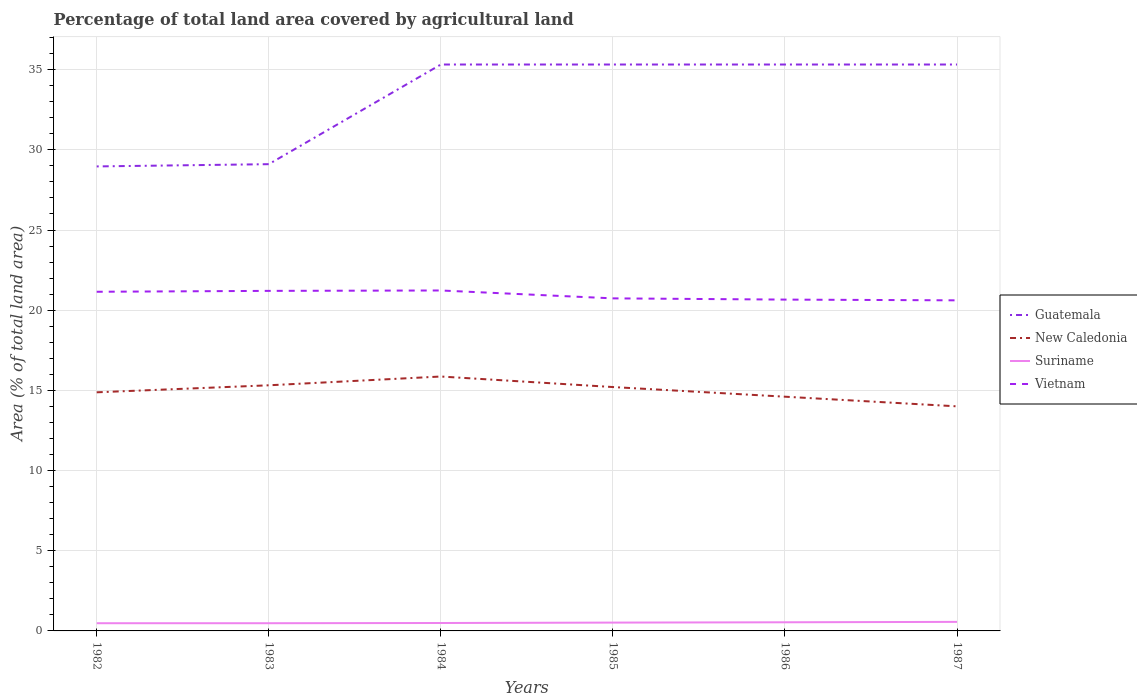How many different coloured lines are there?
Give a very brief answer. 4. Is the number of lines equal to the number of legend labels?
Make the answer very short. Yes. Across all years, what is the maximum percentage of agricultural land in Guatemala?
Offer a very short reply. 28.97. In which year was the percentage of agricultural land in Vietnam maximum?
Ensure brevity in your answer.  1987. What is the total percentage of agricultural land in Guatemala in the graph?
Your answer should be very brief. 0. What is the difference between the highest and the second highest percentage of agricultural land in New Caledonia?
Provide a succinct answer. 1.86. How many years are there in the graph?
Make the answer very short. 6. How many legend labels are there?
Make the answer very short. 4. What is the title of the graph?
Your answer should be very brief. Percentage of total land area covered by agricultural land. Does "Guinea" appear as one of the legend labels in the graph?
Provide a succinct answer. No. What is the label or title of the Y-axis?
Offer a terse response. Area (% of total land area). What is the Area (% of total land area) in Guatemala in 1982?
Offer a terse response. 28.97. What is the Area (% of total land area) of New Caledonia in 1982?
Ensure brevity in your answer.  14.88. What is the Area (% of total land area) in Suriname in 1982?
Make the answer very short. 0.48. What is the Area (% of total land area) of Vietnam in 1982?
Make the answer very short. 21.15. What is the Area (% of total land area) in Guatemala in 1983?
Keep it short and to the point. 29.11. What is the Area (% of total land area) of New Caledonia in 1983?
Keep it short and to the point. 15.32. What is the Area (% of total land area) in Suriname in 1983?
Keep it short and to the point. 0.48. What is the Area (% of total land area) of Vietnam in 1983?
Your answer should be very brief. 21.2. What is the Area (% of total land area) of Guatemala in 1984?
Provide a succinct answer. 35.32. What is the Area (% of total land area) of New Caledonia in 1984?
Provide a succinct answer. 15.86. What is the Area (% of total land area) in Suriname in 1984?
Provide a short and direct response. 0.49. What is the Area (% of total land area) in Vietnam in 1984?
Give a very brief answer. 21.23. What is the Area (% of total land area) of Guatemala in 1985?
Provide a succinct answer. 35.32. What is the Area (% of total land area) in New Caledonia in 1985?
Your answer should be very brief. 15.21. What is the Area (% of total land area) of Suriname in 1985?
Provide a short and direct response. 0.52. What is the Area (% of total land area) in Vietnam in 1985?
Offer a very short reply. 20.74. What is the Area (% of total land area) in Guatemala in 1986?
Ensure brevity in your answer.  35.32. What is the Area (% of total land area) of New Caledonia in 1986?
Keep it short and to the point. 14.61. What is the Area (% of total land area) of Suriname in 1986?
Your response must be concise. 0.54. What is the Area (% of total land area) of Vietnam in 1986?
Your answer should be very brief. 20.66. What is the Area (% of total land area) in Guatemala in 1987?
Keep it short and to the point. 35.32. What is the Area (% of total land area) of New Caledonia in 1987?
Provide a short and direct response. 14. What is the Area (% of total land area) of Suriname in 1987?
Ensure brevity in your answer.  0.56. What is the Area (% of total land area) in Vietnam in 1987?
Provide a succinct answer. 20.62. Across all years, what is the maximum Area (% of total land area) of Guatemala?
Ensure brevity in your answer.  35.32. Across all years, what is the maximum Area (% of total land area) in New Caledonia?
Your answer should be compact. 15.86. Across all years, what is the maximum Area (% of total land area) in Suriname?
Make the answer very short. 0.56. Across all years, what is the maximum Area (% of total land area) of Vietnam?
Offer a very short reply. 21.23. Across all years, what is the minimum Area (% of total land area) of Guatemala?
Provide a succinct answer. 28.97. Across all years, what is the minimum Area (% of total land area) in New Caledonia?
Provide a short and direct response. 14. Across all years, what is the minimum Area (% of total land area) of Suriname?
Offer a very short reply. 0.48. Across all years, what is the minimum Area (% of total land area) of Vietnam?
Make the answer very short. 20.62. What is the total Area (% of total land area) in Guatemala in the graph?
Make the answer very short. 199.36. What is the total Area (% of total land area) in New Caledonia in the graph?
Keep it short and to the point. 89.88. What is the total Area (% of total land area) in Suriname in the graph?
Your answer should be very brief. 3.08. What is the total Area (% of total land area) of Vietnam in the graph?
Offer a very short reply. 125.6. What is the difference between the Area (% of total land area) of Guatemala in 1982 and that in 1983?
Ensure brevity in your answer.  -0.14. What is the difference between the Area (% of total land area) of New Caledonia in 1982 and that in 1983?
Offer a terse response. -0.44. What is the difference between the Area (% of total land area) of Vietnam in 1982 and that in 1983?
Your answer should be very brief. -0.06. What is the difference between the Area (% of total land area) of Guatemala in 1982 and that in 1984?
Offer a terse response. -6.36. What is the difference between the Area (% of total land area) in New Caledonia in 1982 and that in 1984?
Provide a succinct answer. -0.98. What is the difference between the Area (% of total land area) of Suriname in 1982 and that in 1984?
Make the answer very short. -0.01. What is the difference between the Area (% of total land area) in Vietnam in 1982 and that in 1984?
Your answer should be very brief. -0.08. What is the difference between the Area (% of total land area) in Guatemala in 1982 and that in 1985?
Make the answer very short. -6.36. What is the difference between the Area (% of total land area) of New Caledonia in 1982 and that in 1985?
Your response must be concise. -0.33. What is the difference between the Area (% of total land area) of Suriname in 1982 and that in 1985?
Provide a succinct answer. -0.04. What is the difference between the Area (% of total land area) of Vietnam in 1982 and that in 1985?
Give a very brief answer. 0.41. What is the difference between the Area (% of total land area) of Guatemala in 1982 and that in 1986?
Provide a succinct answer. -6.36. What is the difference between the Area (% of total land area) in New Caledonia in 1982 and that in 1986?
Offer a terse response. 0.27. What is the difference between the Area (% of total land area) in Suriname in 1982 and that in 1986?
Your answer should be very brief. -0.06. What is the difference between the Area (% of total land area) of Vietnam in 1982 and that in 1986?
Keep it short and to the point. 0.49. What is the difference between the Area (% of total land area) in Guatemala in 1982 and that in 1987?
Offer a very short reply. -6.36. What is the difference between the Area (% of total land area) of New Caledonia in 1982 and that in 1987?
Your answer should be compact. 0.88. What is the difference between the Area (% of total land area) in Suriname in 1982 and that in 1987?
Ensure brevity in your answer.  -0.08. What is the difference between the Area (% of total land area) in Vietnam in 1982 and that in 1987?
Your answer should be compact. 0.53. What is the difference between the Area (% of total land area) in Guatemala in 1983 and that in 1984?
Offer a very short reply. -6.21. What is the difference between the Area (% of total land area) of New Caledonia in 1983 and that in 1984?
Give a very brief answer. -0.55. What is the difference between the Area (% of total land area) in Suriname in 1983 and that in 1984?
Offer a terse response. -0.01. What is the difference between the Area (% of total land area) of Vietnam in 1983 and that in 1984?
Your response must be concise. -0.02. What is the difference between the Area (% of total land area) in Guatemala in 1983 and that in 1985?
Provide a succinct answer. -6.21. What is the difference between the Area (% of total land area) in New Caledonia in 1983 and that in 1985?
Offer a terse response. 0.11. What is the difference between the Area (% of total land area) in Suriname in 1983 and that in 1985?
Offer a terse response. -0.04. What is the difference between the Area (% of total land area) of Vietnam in 1983 and that in 1985?
Your response must be concise. 0.47. What is the difference between the Area (% of total land area) of Guatemala in 1983 and that in 1986?
Offer a terse response. -6.21. What is the difference between the Area (% of total land area) of New Caledonia in 1983 and that in 1986?
Your answer should be very brief. 0.71. What is the difference between the Area (% of total land area) of Suriname in 1983 and that in 1986?
Your response must be concise. -0.06. What is the difference between the Area (% of total land area) of Vietnam in 1983 and that in 1986?
Provide a succinct answer. 0.54. What is the difference between the Area (% of total land area) of Guatemala in 1983 and that in 1987?
Keep it short and to the point. -6.21. What is the difference between the Area (% of total land area) of New Caledonia in 1983 and that in 1987?
Provide a short and direct response. 1.31. What is the difference between the Area (% of total land area) of Suriname in 1983 and that in 1987?
Provide a succinct answer. -0.08. What is the difference between the Area (% of total land area) of Vietnam in 1983 and that in 1987?
Ensure brevity in your answer.  0.59. What is the difference between the Area (% of total land area) of Guatemala in 1984 and that in 1985?
Make the answer very short. 0. What is the difference between the Area (% of total land area) of New Caledonia in 1984 and that in 1985?
Your response must be concise. 0.66. What is the difference between the Area (% of total land area) in Suriname in 1984 and that in 1985?
Offer a very short reply. -0.03. What is the difference between the Area (% of total land area) in Vietnam in 1984 and that in 1985?
Your response must be concise. 0.49. What is the difference between the Area (% of total land area) of New Caledonia in 1984 and that in 1986?
Provide a short and direct response. 1.26. What is the difference between the Area (% of total land area) in Suriname in 1984 and that in 1986?
Offer a very short reply. -0.04. What is the difference between the Area (% of total land area) of Vietnam in 1984 and that in 1986?
Offer a very short reply. 0.57. What is the difference between the Area (% of total land area) of New Caledonia in 1984 and that in 1987?
Keep it short and to the point. 1.86. What is the difference between the Area (% of total land area) of Suriname in 1984 and that in 1987?
Offer a terse response. -0.07. What is the difference between the Area (% of total land area) of Vietnam in 1984 and that in 1987?
Give a very brief answer. 0.61. What is the difference between the Area (% of total land area) in New Caledonia in 1985 and that in 1986?
Keep it short and to the point. 0.6. What is the difference between the Area (% of total land area) in Suriname in 1985 and that in 1986?
Your answer should be compact. -0.02. What is the difference between the Area (% of total land area) of Vietnam in 1985 and that in 1986?
Give a very brief answer. 0.08. What is the difference between the Area (% of total land area) in New Caledonia in 1985 and that in 1987?
Your answer should be compact. 1.2. What is the difference between the Area (% of total land area) in Suriname in 1985 and that in 1987?
Provide a succinct answer. -0.04. What is the difference between the Area (% of total land area) of Vietnam in 1985 and that in 1987?
Your answer should be compact. 0.12. What is the difference between the Area (% of total land area) in Guatemala in 1986 and that in 1987?
Give a very brief answer. 0. What is the difference between the Area (% of total land area) of New Caledonia in 1986 and that in 1987?
Offer a very short reply. 0.6. What is the difference between the Area (% of total land area) in Suriname in 1986 and that in 1987?
Offer a very short reply. -0.03. What is the difference between the Area (% of total land area) in Vietnam in 1986 and that in 1987?
Ensure brevity in your answer.  0.05. What is the difference between the Area (% of total land area) in Guatemala in 1982 and the Area (% of total land area) in New Caledonia in 1983?
Give a very brief answer. 13.65. What is the difference between the Area (% of total land area) in Guatemala in 1982 and the Area (% of total land area) in Suriname in 1983?
Your answer should be compact. 28.49. What is the difference between the Area (% of total land area) of Guatemala in 1982 and the Area (% of total land area) of Vietnam in 1983?
Ensure brevity in your answer.  7.76. What is the difference between the Area (% of total land area) of New Caledonia in 1982 and the Area (% of total land area) of Suriname in 1983?
Keep it short and to the point. 14.4. What is the difference between the Area (% of total land area) in New Caledonia in 1982 and the Area (% of total land area) in Vietnam in 1983?
Ensure brevity in your answer.  -6.33. What is the difference between the Area (% of total land area) of Suriname in 1982 and the Area (% of total land area) of Vietnam in 1983?
Provide a succinct answer. -20.72. What is the difference between the Area (% of total land area) in Guatemala in 1982 and the Area (% of total land area) in New Caledonia in 1984?
Your response must be concise. 13.1. What is the difference between the Area (% of total land area) in Guatemala in 1982 and the Area (% of total land area) in Suriname in 1984?
Make the answer very short. 28.47. What is the difference between the Area (% of total land area) in Guatemala in 1982 and the Area (% of total land area) in Vietnam in 1984?
Offer a terse response. 7.74. What is the difference between the Area (% of total land area) in New Caledonia in 1982 and the Area (% of total land area) in Suriname in 1984?
Your answer should be very brief. 14.39. What is the difference between the Area (% of total land area) in New Caledonia in 1982 and the Area (% of total land area) in Vietnam in 1984?
Your response must be concise. -6.35. What is the difference between the Area (% of total land area) of Suriname in 1982 and the Area (% of total land area) of Vietnam in 1984?
Offer a terse response. -20.75. What is the difference between the Area (% of total land area) in Guatemala in 1982 and the Area (% of total land area) in New Caledonia in 1985?
Provide a succinct answer. 13.76. What is the difference between the Area (% of total land area) of Guatemala in 1982 and the Area (% of total land area) of Suriname in 1985?
Your answer should be compact. 28.45. What is the difference between the Area (% of total land area) of Guatemala in 1982 and the Area (% of total land area) of Vietnam in 1985?
Provide a short and direct response. 8.23. What is the difference between the Area (% of total land area) of New Caledonia in 1982 and the Area (% of total land area) of Suriname in 1985?
Your response must be concise. 14.36. What is the difference between the Area (% of total land area) of New Caledonia in 1982 and the Area (% of total land area) of Vietnam in 1985?
Make the answer very short. -5.86. What is the difference between the Area (% of total land area) in Suriname in 1982 and the Area (% of total land area) in Vietnam in 1985?
Your answer should be compact. -20.26. What is the difference between the Area (% of total land area) of Guatemala in 1982 and the Area (% of total land area) of New Caledonia in 1986?
Offer a very short reply. 14.36. What is the difference between the Area (% of total land area) in Guatemala in 1982 and the Area (% of total land area) in Suriname in 1986?
Give a very brief answer. 28.43. What is the difference between the Area (% of total land area) of Guatemala in 1982 and the Area (% of total land area) of Vietnam in 1986?
Give a very brief answer. 8.3. What is the difference between the Area (% of total land area) of New Caledonia in 1982 and the Area (% of total land area) of Suriname in 1986?
Provide a succinct answer. 14.34. What is the difference between the Area (% of total land area) in New Caledonia in 1982 and the Area (% of total land area) in Vietnam in 1986?
Ensure brevity in your answer.  -5.78. What is the difference between the Area (% of total land area) in Suriname in 1982 and the Area (% of total land area) in Vietnam in 1986?
Ensure brevity in your answer.  -20.18. What is the difference between the Area (% of total land area) in Guatemala in 1982 and the Area (% of total land area) in New Caledonia in 1987?
Ensure brevity in your answer.  14.96. What is the difference between the Area (% of total land area) in Guatemala in 1982 and the Area (% of total land area) in Suriname in 1987?
Your answer should be very brief. 28.4. What is the difference between the Area (% of total land area) of Guatemala in 1982 and the Area (% of total land area) of Vietnam in 1987?
Provide a short and direct response. 8.35. What is the difference between the Area (% of total land area) in New Caledonia in 1982 and the Area (% of total land area) in Suriname in 1987?
Make the answer very short. 14.32. What is the difference between the Area (% of total land area) of New Caledonia in 1982 and the Area (% of total land area) of Vietnam in 1987?
Offer a very short reply. -5.74. What is the difference between the Area (% of total land area) of Suriname in 1982 and the Area (% of total land area) of Vietnam in 1987?
Offer a terse response. -20.13. What is the difference between the Area (% of total land area) of Guatemala in 1983 and the Area (% of total land area) of New Caledonia in 1984?
Make the answer very short. 13.24. What is the difference between the Area (% of total land area) of Guatemala in 1983 and the Area (% of total land area) of Suriname in 1984?
Make the answer very short. 28.61. What is the difference between the Area (% of total land area) in Guatemala in 1983 and the Area (% of total land area) in Vietnam in 1984?
Your answer should be very brief. 7.88. What is the difference between the Area (% of total land area) in New Caledonia in 1983 and the Area (% of total land area) in Suriname in 1984?
Your answer should be very brief. 14.82. What is the difference between the Area (% of total land area) of New Caledonia in 1983 and the Area (% of total land area) of Vietnam in 1984?
Ensure brevity in your answer.  -5.91. What is the difference between the Area (% of total land area) of Suriname in 1983 and the Area (% of total land area) of Vietnam in 1984?
Offer a very short reply. -20.75. What is the difference between the Area (% of total land area) in Guatemala in 1983 and the Area (% of total land area) in New Caledonia in 1985?
Your response must be concise. 13.9. What is the difference between the Area (% of total land area) of Guatemala in 1983 and the Area (% of total land area) of Suriname in 1985?
Make the answer very short. 28.59. What is the difference between the Area (% of total land area) of Guatemala in 1983 and the Area (% of total land area) of Vietnam in 1985?
Ensure brevity in your answer.  8.37. What is the difference between the Area (% of total land area) of New Caledonia in 1983 and the Area (% of total land area) of Suriname in 1985?
Provide a succinct answer. 14.8. What is the difference between the Area (% of total land area) of New Caledonia in 1983 and the Area (% of total land area) of Vietnam in 1985?
Give a very brief answer. -5.42. What is the difference between the Area (% of total land area) in Suriname in 1983 and the Area (% of total land area) in Vietnam in 1985?
Your answer should be compact. -20.26. What is the difference between the Area (% of total land area) in Guatemala in 1983 and the Area (% of total land area) in New Caledonia in 1986?
Provide a short and direct response. 14.5. What is the difference between the Area (% of total land area) in Guatemala in 1983 and the Area (% of total land area) in Suriname in 1986?
Offer a terse response. 28.57. What is the difference between the Area (% of total land area) of Guatemala in 1983 and the Area (% of total land area) of Vietnam in 1986?
Provide a succinct answer. 8.44. What is the difference between the Area (% of total land area) of New Caledonia in 1983 and the Area (% of total land area) of Suriname in 1986?
Your response must be concise. 14.78. What is the difference between the Area (% of total land area) of New Caledonia in 1983 and the Area (% of total land area) of Vietnam in 1986?
Your answer should be very brief. -5.34. What is the difference between the Area (% of total land area) in Suriname in 1983 and the Area (% of total land area) in Vietnam in 1986?
Make the answer very short. -20.18. What is the difference between the Area (% of total land area) in Guatemala in 1983 and the Area (% of total land area) in New Caledonia in 1987?
Offer a terse response. 15.1. What is the difference between the Area (% of total land area) of Guatemala in 1983 and the Area (% of total land area) of Suriname in 1987?
Your response must be concise. 28.54. What is the difference between the Area (% of total land area) in Guatemala in 1983 and the Area (% of total land area) in Vietnam in 1987?
Give a very brief answer. 8.49. What is the difference between the Area (% of total land area) in New Caledonia in 1983 and the Area (% of total land area) in Suriname in 1987?
Give a very brief answer. 14.75. What is the difference between the Area (% of total land area) of New Caledonia in 1983 and the Area (% of total land area) of Vietnam in 1987?
Ensure brevity in your answer.  -5.3. What is the difference between the Area (% of total land area) in Suriname in 1983 and the Area (% of total land area) in Vietnam in 1987?
Give a very brief answer. -20.13. What is the difference between the Area (% of total land area) of Guatemala in 1984 and the Area (% of total land area) of New Caledonia in 1985?
Offer a very short reply. 20.11. What is the difference between the Area (% of total land area) in Guatemala in 1984 and the Area (% of total land area) in Suriname in 1985?
Your response must be concise. 34.8. What is the difference between the Area (% of total land area) in Guatemala in 1984 and the Area (% of total land area) in Vietnam in 1985?
Your response must be concise. 14.58. What is the difference between the Area (% of total land area) in New Caledonia in 1984 and the Area (% of total land area) in Suriname in 1985?
Your answer should be compact. 15.35. What is the difference between the Area (% of total land area) in New Caledonia in 1984 and the Area (% of total land area) in Vietnam in 1985?
Provide a short and direct response. -4.87. What is the difference between the Area (% of total land area) in Suriname in 1984 and the Area (% of total land area) in Vietnam in 1985?
Provide a short and direct response. -20.24. What is the difference between the Area (% of total land area) of Guatemala in 1984 and the Area (% of total land area) of New Caledonia in 1986?
Offer a terse response. 20.71. What is the difference between the Area (% of total land area) in Guatemala in 1984 and the Area (% of total land area) in Suriname in 1986?
Your answer should be compact. 34.78. What is the difference between the Area (% of total land area) in Guatemala in 1984 and the Area (% of total land area) in Vietnam in 1986?
Offer a very short reply. 14.66. What is the difference between the Area (% of total land area) of New Caledonia in 1984 and the Area (% of total land area) of Suriname in 1986?
Provide a short and direct response. 15.33. What is the difference between the Area (% of total land area) of New Caledonia in 1984 and the Area (% of total land area) of Vietnam in 1986?
Your answer should be very brief. -4.8. What is the difference between the Area (% of total land area) in Suriname in 1984 and the Area (% of total land area) in Vietnam in 1986?
Provide a short and direct response. -20.17. What is the difference between the Area (% of total land area) in Guatemala in 1984 and the Area (% of total land area) in New Caledonia in 1987?
Provide a succinct answer. 21.32. What is the difference between the Area (% of total land area) of Guatemala in 1984 and the Area (% of total land area) of Suriname in 1987?
Make the answer very short. 34.76. What is the difference between the Area (% of total land area) in Guatemala in 1984 and the Area (% of total land area) in Vietnam in 1987?
Keep it short and to the point. 14.71. What is the difference between the Area (% of total land area) of New Caledonia in 1984 and the Area (% of total land area) of Suriname in 1987?
Make the answer very short. 15.3. What is the difference between the Area (% of total land area) in New Caledonia in 1984 and the Area (% of total land area) in Vietnam in 1987?
Provide a short and direct response. -4.75. What is the difference between the Area (% of total land area) in Suriname in 1984 and the Area (% of total land area) in Vietnam in 1987?
Offer a very short reply. -20.12. What is the difference between the Area (% of total land area) of Guatemala in 1985 and the Area (% of total land area) of New Caledonia in 1986?
Make the answer very short. 20.71. What is the difference between the Area (% of total land area) of Guatemala in 1985 and the Area (% of total land area) of Suriname in 1986?
Offer a very short reply. 34.78. What is the difference between the Area (% of total land area) of Guatemala in 1985 and the Area (% of total land area) of Vietnam in 1986?
Your answer should be compact. 14.66. What is the difference between the Area (% of total land area) in New Caledonia in 1985 and the Area (% of total land area) in Suriname in 1986?
Keep it short and to the point. 14.67. What is the difference between the Area (% of total land area) in New Caledonia in 1985 and the Area (% of total land area) in Vietnam in 1986?
Ensure brevity in your answer.  -5.45. What is the difference between the Area (% of total land area) in Suriname in 1985 and the Area (% of total land area) in Vietnam in 1986?
Offer a very short reply. -20.14. What is the difference between the Area (% of total land area) of Guatemala in 1985 and the Area (% of total land area) of New Caledonia in 1987?
Give a very brief answer. 21.32. What is the difference between the Area (% of total land area) in Guatemala in 1985 and the Area (% of total land area) in Suriname in 1987?
Keep it short and to the point. 34.76. What is the difference between the Area (% of total land area) in Guatemala in 1985 and the Area (% of total land area) in Vietnam in 1987?
Provide a short and direct response. 14.71. What is the difference between the Area (% of total land area) in New Caledonia in 1985 and the Area (% of total land area) in Suriname in 1987?
Ensure brevity in your answer.  14.64. What is the difference between the Area (% of total land area) in New Caledonia in 1985 and the Area (% of total land area) in Vietnam in 1987?
Your answer should be compact. -5.41. What is the difference between the Area (% of total land area) in Suriname in 1985 and the Area (% of total land area) in Vietnam in 1987?
Your answer should be compact. -20.1. What is the difference between the Area (% of total land area) of Guatemala in 1986 and the Area (% of total land area) of New Caledonia in 1987?
Your response must be concise. 21.32. What is the difference between the Area (% of total land area) in Guatemala in 1986 and the Area (% of total land area) in Suriname in 1987?
Offer a very short reply. 34.76. What is the difference between the Area (% of total land area) in Guatemala in 1986 and the Area (% of total land area) in Vietnam in 1987?
Offer a terse response. 14.71. What is the difference between the Area (% of total land area) of New Caledonia in 1986 and the Area (% of total land area) of Suriname in 1987?
Provide a succinct answer. 14.04. What is the difference between the Area (% of total land area) of New Caledonia in 1986 and the Area (% of total land area) of Vietnam in 1987?
Keep it short and to the point. -6.01. What is the difference between the Area (% of total land area) in Suriname in 1986 and the Area (% of total land area) in Vietnam in 1987?
Make the answer very short. -20.08. What is the average Area (% of total land area) of Guatemala per year?
Make the answer very short. 33.23. What is the average Area (% of total land area) of New Caledonia per year?
Provide a succinct answer. 14.98. What is the average Area (% of total land area) of Suriname per year?
Your response must be concise. 0.51. What is the average Area (% of total land area) of Vietnam per year?
Your answer should be very brief. 20.93. In the year 1982, what is the difference between the Area (% of total land area) of Guatemala and Area (% of total land area) of New Caledonia?
Keep it short and to the point. 14.09. In the year 1982, what is the difference between the Area (% of total land area) in Guatemala and Area (% of total land area) in Suriname?
Ensure brevity in your answer.  28.49. In the year 1982, what is the difference between the Area (% of total land area) in Guatemala and Area (% of total land area) in Vietnam?
Ensure brevity in your answer.  7.82. In the year 1982, what is the difference between the Area (% of total land area) in New Caledonia and Area (% of total land area) in Suriname?
Give a very brief answer. 14.4. In the year 1982, what is the difference between the Area (% of total land area) in New Caledonia and Area (% of total land area) in Vietnam?
Keep it short and to the point. -6.27. In the year 1982, what is the difference between the Area (% of total land area) in Suriname and Area (% of total land area) in Vietnam?
Provide a succinct answer. -20.67. In the year 1983, what is the difference between the Area (% of total land area) in Guatemala and Area (% of total land area) in New Caledonia?
Keep it short and to the point. 13.79. In the year 1983, what is the difference between the Area (% of total land area) in Guatemala and Area (% of total land area) in Suriname?
Provide a short and direct response. 28.63. In the year 1983, what is the difference between the Area (% of total land area) of Guatemala and Area (% of total land area) of Vietnam?
Offer a very short reply. 7.9. In the year 1983, what is the difference between the Area (% of total land area) in New Caledonia and Area (% of total land area) in Suriname?
Give a very brief answer. 14.84. In the year 1983, what is the difference between the Area (% of total land area) in New Caledonia and Area (% of total land area) in Vietnam?
Your response must be concise. -5.89. In the year 1983, what is the difference between the Area (% of total land area) in Suriname and Area (% of total land area) in Vietnam?
Keep it short and to the point. -20.72. In the year 1984, what is the difference between the Area (% of total land area) in Guatemala and Area (% of total land area) in New Caledonia?
Your answer should be compact. 19.46. In the year 1984, what is the difference between the Area (% of total land area) of Guatemala and Area (% of total land area) of Suriname?
Offer a very short reply. 34.83. In the year 1984, what is the difference between the Area (% of total land area) in Guatemala and Area (% of total land area) in Vietnam?
Give a very brief answer. 14.09. In the year 1984, what is the difference between the Area (% of total land area) in New Caledonia and Area (% of total land area) in Suriname?
Your answer should be very brief. 15.37. In the year 1984, what is the difference between the Area (% of total land area) of New Caledonia and Area (% of total land area) of Vietnam?
Offer a very short reply. -5.37. In the year 1984, what is the difference between the Area (% of total land area) in Suriname and Area (% of total land area) in Vietnam?
Make the answer very short. -20.74. In the year 1985, what is the difference between the Area (% of total land area) in Guatemala and Area (% of total land area) in New Caledonia?
Provide a succinct answer. 20.11. In the year 1985, what is the difference between the Area (% of total land area) in Guatemala and Area (% of total land area) in Suriname?
Your answer should be very brief. 34.8. In the year 1985, what is the difference between the Area (% of total land area) in Guatemala and Area (% of total land area) in Vietnam?
Ensure brevity in your answer.  14.58. In the year 1985, what is the difference between the Area (% of total land area) in New Caledonia and Area (% of total land area) in Suriname?
Provide a short and direct response. 14.69. In the year 1985, what is the difference between the Area (% of total land area) of New Caledonia and Area (% of total land area) of Vietnam?
Provide a succinct answer. -5.53. In the year 1985, what is the difference between the Area (% of total land area) in Suriname and Area (% of total land area) in Vietnam?
Ensure brevity in your answer.  -20.22. In the year 1986, what is the difference between the Area (% of total land area) of Guatemala and Area (% of total land area) of New Caledonia?
Keep it short and to the point. 20.71. In the year 1986, what is the difference between the Area (% of total land area) in Guatemala and Area (% of total land area) in Suriname?
Provide a short and direct response. 34.78. In the year 1986, what is the difference between the Area (% of total land area) in Guatemala and Area (% of total land area) in Vietnam?
Provide a short and direct response. 14.66. In the year 1986, what is the difference between the Area (% of total land area) of New Caledonia and Area (% of total land area) of Suriname?
Your response must be concise. 14.07. In the year 1986, what is the difference between the Area (% of total land area) of New Caledonia and Area (% of total land area) of Vietnam?
Your answer should be very brief. -6.05. In the year 1986, what is the difference between the Area (% of total land area) of Suriname and Area (% of total land area) of Vietnam?
Offer a very short reply. -20.12. In the year 1987, what is the difference between the Area (% of total land area) of Guatemala and Area (% of total land area) of New Caledonia?
Ensure brevity in your answer.  21.32. In the year 1987, what is the difference between the Area (% of total land area) of Guatemala and Area (% of total land area) of Suriname?
Provide a short and direct response. 34.76. In the year 1987, what is the difference between the Area (% of total land area) of Guatemala and Area (% of total land area) of Vietnam?
Give a very brief answer. 14.71. In the year 1987, what is the difference between the Area (% of total land area) in New Caledonia and Area (% of total land area) in Suriname?
Offer a very short reply. 13.44. In the year 1987, what is the difference between the Area (% of total land area) in New Caledonia and Area (% of total land area) in Vietnam?
Give a very brief answer. -6.61. In the year 1987, what is the difference between the Area (% of total land area) in Suriname and Area (% of total land area) in Vietnam?
Keep it short and to the point. -20.05. What is the ratio of the Area (% of total land area) in Guatemala in 1982 to that in 1983?
Give a very brief answer. 1. What is the ratio of the Area (% of total land area) of New Caledonia in 1982 to that in 1983?
Give a very brief answer. 0.97. What is the ratio of the Area (% of total land area) of Suriname in 1982 to that in 1983?
Make the answer very short. 1. What is the ratio of the Area (% of total land area) in Guatemala in 1982 to that in 1984?
Your response must be concise. 0.82. What is the ratio of the Area (% of total land area) in New Caledonia in 1982 to that in 1984?
Provide a short and direct response. 0.94. What is the ratio of the Area (% of total land area) of Suriname in 1982 to that in 1984?
Keep it short and to the point. 0.97. What is the ratio of the Area (% of total land area) in Vietnam in 1982 to that in 1984?
Make the answer very short. 1. What is the ratio of the Area (% of total land area) of Guatemala in 1982 to that in 1985?
Provide a succinct answer. 0.82. What is the ratio of the Area (% of total land area) of New Caledonia in 1982 to that in 1985?
Your answer should be compact. 0.98. What is the ratio of the Area (% of total land area) of Suriname in 1982 to that in 1985?
Keep it short and to the point. 0.93. What is the ratio of the Area (% of total land area) in Vietnam in 1982 to that in 1985?
Offer a terse response. 1.02. What is the ratio of the Area (% of total land area) in Guatemala in 1982 to that in 1986?
Keep it short and to the point. 0.82. What is the ratio of the Area (% of total land area) in New Caledonia in 1982 to that in 1986?
Give a very brief answer. 1.02. What is the ratio of the Area (% of total land area) in Suriname in 1982 to that in 1986?
Keep it short and to the point. 0.89. What is the ratio of the Area (% of total land area) of Vietnam in 1982 to that in 1986?
Make the answer very short. 1.02. What is the ratio of the Area (% of total land area) of Guatemala in 1982 to that in 1987?
Your answer should be very brief. 0.82. What is the ratio of the Area (% of total land area) in New Caledonia in 1982 to that in 1987?
Provide a short and direct response. 1.06. What is the ratio of the Area (% of total land area) in Suriname in 1982 to that in 1987?
Your answer should be very brief. 0.85. What is the ratio of the Area (% of total land area) of Vietnam in 1982 to that in 1987?
Your answer should be very brief. 1.03. What is the ratio of the Area (% of total land area) in Guatemala in 1983 to that in 1984?
Provide a succinct answer. 0.82. What is the ratio of the Area (% of total land area) in New Caledonia in 1983 to that in 1984?
Provide a short and direct response. 0.97. What is the ratio of the Area (% of total land area) of Vietnam in 1983 to that in 1984?
Offer a very short reply. 1. What is the ratio of the Area (% of total land area) in Guatemala in 1983 to that in 1985?
Offer a terse response. 0.82. What is the ratio of the Area (% of total land area) in New Caledonia in 1983 to that in 1985?
Keep it short and to the point. 1.01. What is the ratio of the Area (% of total land area) of Suriname in 1983 to that in 1985?
Your answer should be compact. 0.93. What is the ratio of the Area (% of total land area) of Vietnam in 1983 to that in 1985?
Your response must be concise. 1.02. What is the ratio of the Area (% of total land area) in Guatemala in 1983 to that in 1986?
Your response must be concise. 0.82. What is the ratio of the Area (% of total land area) in New Caledonia in 1983 to that in 1986?
Keep it short and to the point. 1.05. What is the ratio of the Area (% of total land area) of Suriname in 1983 to that in 1986?
Your answer should be compact. 0.89. What is the ratio of the Area (% of total land area) of Vietnam in 1983 to that in 1986?
Keep it short and to the point. 1.03. What is the ratio of the Area (% of total land area) of Guatemala in 1983 to that in 1987?
Ensure brevity in your answer.  0.82. What is the ratio of the Area (% of total land area) in New Caledonia in 1983 to that in 1987?
Ensure brevity in your answer.  1.09. What is the ratio of the Area (% of total land area) in Suriname in 1983 to that in 1987?
Your answer should be compact. 0.85. What is the ratio of the Area (% of total land area) in Vietnam in 1983 to that in 1987?
Give a very brief answer. 1.03. What is the ratio of the Area (% of total land area) in Guatemala in 1984 to that in 1985?
Offer a terse response. 1. What is the ratio of the Area (% of total land area) in New Caledonia in 1984 to that in 1985?
Provide a succinct answer. 1.04. What is the ratio of the Area (% of total land area) in Suriname in 1984 to that in 1985?
Give a very brief answer. 0.95. What is the ratio of the Area (% of total land area) in Vietnam in 1984 to that in 1985?
Your answer should be compact. 1.02. What is the ratio of the Area (% of total land area) of Guatemala in 1984 to that in 1986?
Give a very brief answer. 1. What is the ratio of the Area (% of total land area) in New Caledonia in 1984 to that in 1986?
Provide a short and direct response. 1.09. What is the ratio of the Area (% of total land area) in Vietnam in 1984 to that in 1986?
Keep it short and to the point. 1.03. What is the ratio of the Area (% of total land area) of Guatemala in 1984 to that in 1987?
Your answer should be very brief. 1. What is the ratio of the Area (% of total land area) in New Caledonia in 1984 to that in 1987?
Offer a terse response. 1.13. What is the ratio of the Area (% of total land area) of Suriname in 1984 to that in 1987?
Offer a terse response. 0.88. What is the ratio of the Area (% of total land area) in Vietnam in 1984 to that in 1987?
Ensure brevity in your answer.  1.03. What is the ratio of the Area (% of total land area) of New Caledonia in 1985 to that in 1986?
Your answer should be very brief. 1.04. What is the ratio of the Area (% of total land area) of New Caledonia in 1985 to that in 1987?
Offer a very short reply. 1.09. What is the ratio of the Area (% of total land area) in Suriname in 1985 to that in 1987?
Provide a succinct answer. 0.92. What is the ratio of the Area (% of total land area) of Vietnam in 1985 to that in 1987?
Provide a short and direct response. 1.01. What is the ratio of the Area (% of total land area) of New Caledonia in 1986 to that in 1987?
Offer a very short reply. 1.04. What is the ratio of the Area (% of total land area) of Suriname in 1986 to that in 1987?
Give a very brief answer. 0.95. What is the ratio of the Area (% of total land area) of Vietnam in 1986 to that in 1987?
Offer a terse response. 1. What is the difference between the highest and the second highest Area (% of total land area) of Guatemala?
Your answer should be compact. 0. What is the difference between the highest and the second highest Area (% of total land area) of New Caledonia?
Ensure brevity in your answer.  0.55. What is the difference between the highest and the second highest Area (% of total land area) of Suriname?
Provide a short and direct response. 0.03. What is the difference between the highest and the second highest Area (% of total land area) of Vietnam?
Provide a short and direct response. 0.02. What is the difference between the highest and the lowest Area (% of total land area) of Guatemala?
Provide a succinct answer. 6.36. What is the difference between the highest and the lowest Area (% of total land area) of New Caledonia?
Your answer should be very brief. 1.86. What is the difference between the highest and the lowest Area (% of total land area) of Suriname?
Your answer should be very brief. 0.08. What is the difference between the highest and the lowest Area (% of total land area) of Vietnam?
Offer a very short reply. 0.61. 